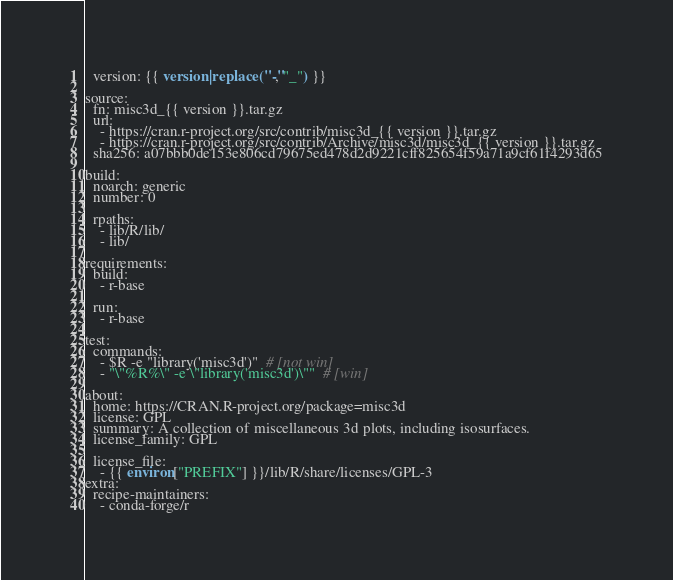Convert code to text. <code><loc_0><loc_0><loc_500><loc_500><_YAML_>  version: {{ version|replace("-", "_") }}

source:
  fn: misc3d_{{ version }}.tar.gz
  url:
    - https://cran.r-project.org/src/contrib/misc3d_{{ version }}.tar.gz
    - https://cran.r-project.org/src/contrib/Archive/misc3d/misc3d_{{ version }}.tar.gz
  sha256: a07bbb0de153e806cd79675ed478d2d9221cff825654f59a71a9cf61f4293d65

build:
  noarch: generic
  number: 0

  rpaths:
    - lib/R/lib/
    - lib/

requirements:
  build:
    - r-base

  run:
    - r-base

test:
  commands:
    - $R -e "library('misc3d')"  # [not win]
    - "\"%R%\" -e \"library('misc3d')\""  # [win]

about:
  home: https://CRAN.R-project.org/package=misc3d
  license: GPL
  summary: A collection of miscellaneous 3d plots, including isosurfaces.
  license_family: GPL

  license_file:
    - {{ environ["PREFIX"] }}/lib/R/share/licenses/GPL-3
extra:
  recipe-maintainers:
    - conda-forge/r
</code> 